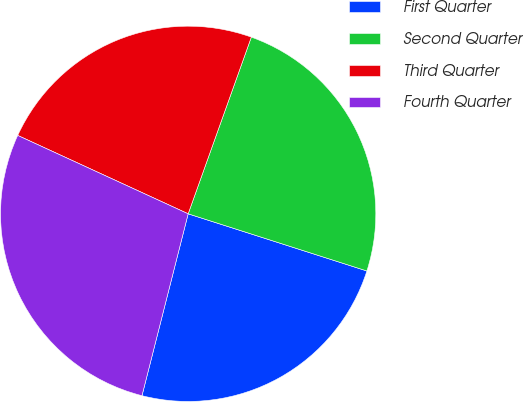<chart> <loc_0><loc_0><loc_500><loc_500><pie_chart><fcel>First Quarter<fcel>Second Quarter<fcel>Third Quarter<fcel>Fourth Quarter<nl><fcel>24.03%<fcel>24.46%<fcel>23.6%<fcel>27.9%<nl></chart> 